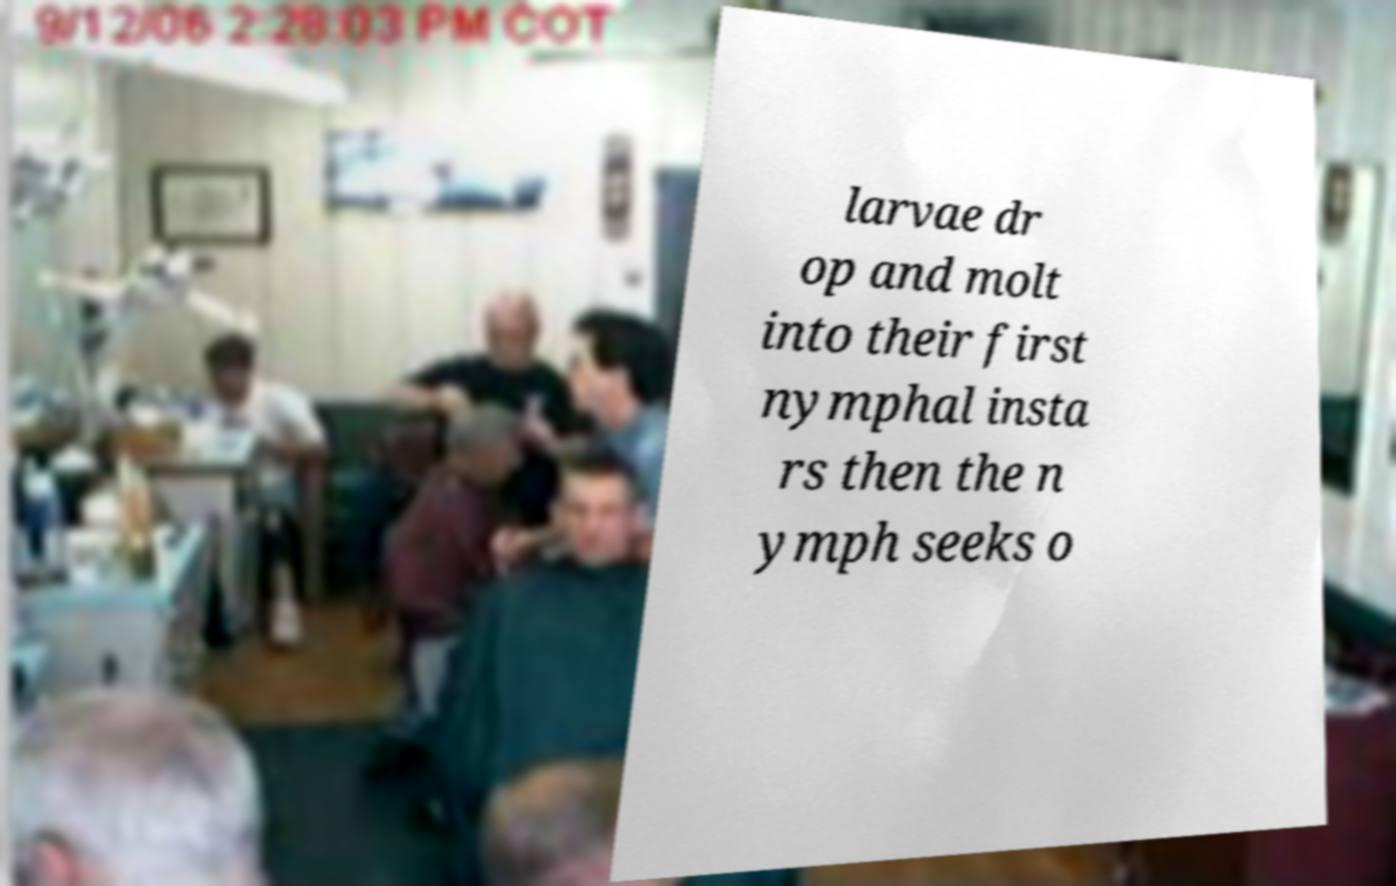I need the written content from this picture converted into text. Can you do that? larvae dr op and molt into their first nymphal insta rs then the n ymph seeks o 